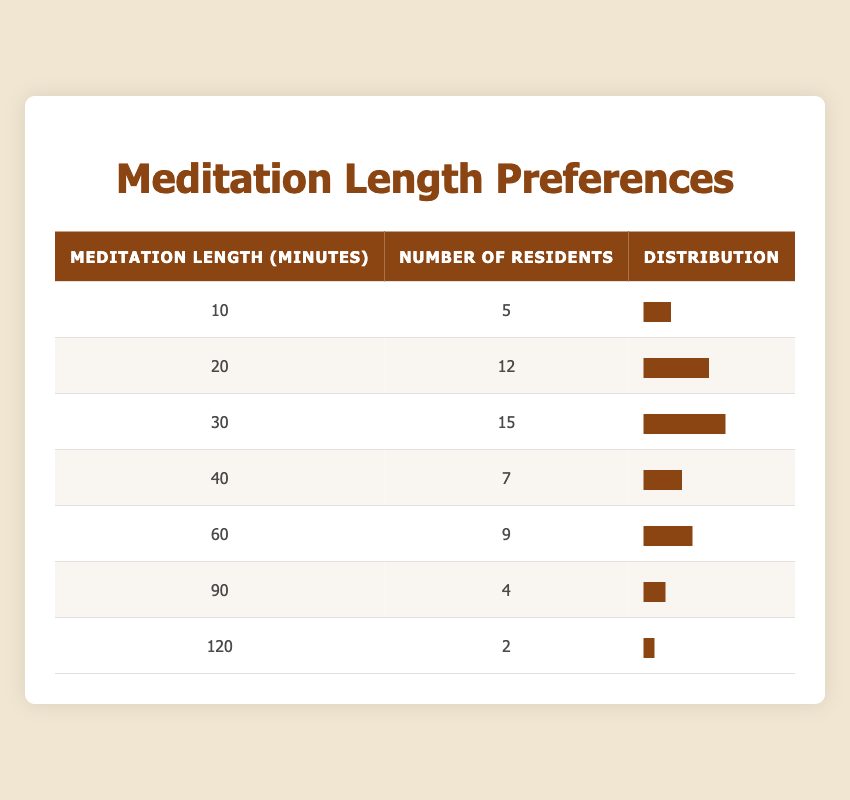What is the number of residents who prefer 30 minutes of meditation? The table shows that 15 residents prefer a length of 30 minutes for meditation, as indicated in the "Number of Residents" column for that specific length.
Answer: 15 How many residents prefer a meditation length of 10 minutes? According to the table, 5 residents prefer to meditate for 10 minutes, as directly shown in the corresponding row.
Answer: 5 Which meditation length has the highest number of residents? By examining the "Number of Residents" column, it is evident that 30 minutes of meditation is preferred by the highest number of residents, which is 15.
Answer: 30 minutes What is the total number of residents who prefer meditation lengths of 60 minutes or longer? To find this, we look at the rows for 60, 90, and 120-minute lengths. Adding the numbers gives us 9 (60 min) + 4 (90 min) + 2 (120 min) = 15 residents preferring these lengths combined.
Answer: 15 Is the number of residents who prefer 40 minutes of meditation greater than those who prefer 120 minutes? The table shows that 7 residents prefer 40 minutes and 2 residents prefer 120 minutes. Since 7 is greater than 2, the statement is true.
Answer: Yes What is the average meditation length preferred by residents? To find the average, we multiply each meditation length by the corresponding number of residents, sum that product, and then divide by the total number of residents. The calculation is as follows: (10*5 + 20*12 + 30*15 + 40*7 + 60*9 + 90*4 + 120*2) / (5 + 12 + 15 + 7 + 9 + 4 + 2) = 25.19, rounding gives an average of approximately 25 minutes.
Answer: 25 minutes How many more residents prefer 20 minutes of meditation compared to 90 minutes? From the table, 12 residents prefer 20 minutes while only 4 prefer 90 minutes. The difference is 12 - 4 = 8 residents.
Answer: 8 Do more residents prefer meditation for 40 minutes than for 30 minutes? The table indicates that 7 residents prefer 40 minutes, while 15 residents prefer 30 minutes. Since 15 is greater than 7, the statement is false.
Answer: No What is the combined total of residents who prefer meditation for lengths of 10, 20, and 30 minutes? To find this total, we add the number of residents for those lengths: 5 (10 min) + 12 (20 min) + 15 (30 min) = 32 residents.
Answer: 32 